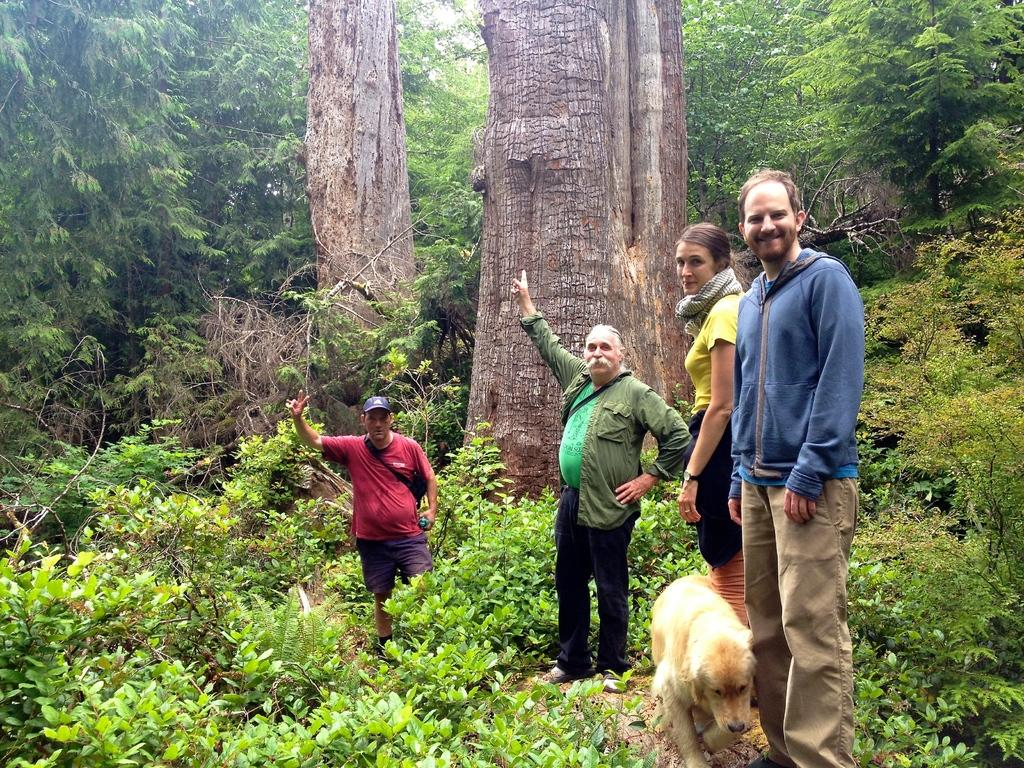What type of animal can be seen in the image? There is a dog present in the image. How many people are in the image? There are four persons in the image. What type of vegetation is visible in the image? There are plants and trees in the image. What type of building can be seen in the image? There is no building present in the image. What type of face does the dog have in the image? The image does not show the dog's face, only its body. 